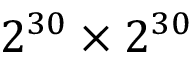<formula> <loc_0><loc_0><loc_500><loc_500>2 ^ { 3 0 } \times 2 ^ { 3 0 }</formula> 